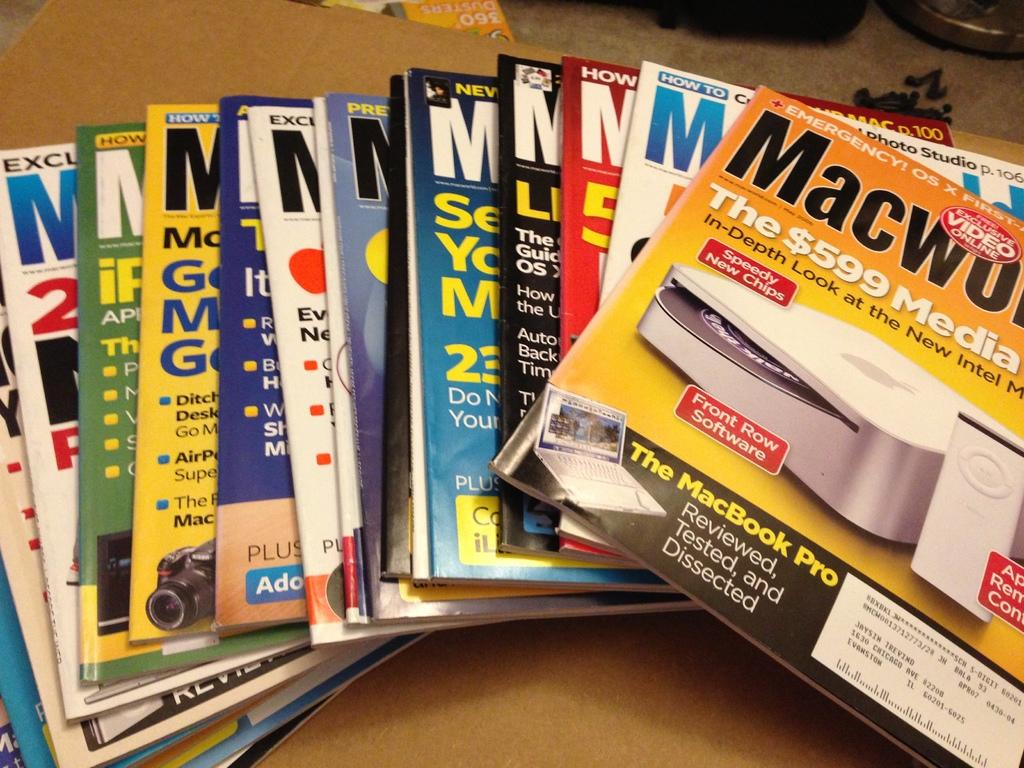<image>
Render a clear and concise summary of the photo. Many Macworld magazines stacked on top each other 